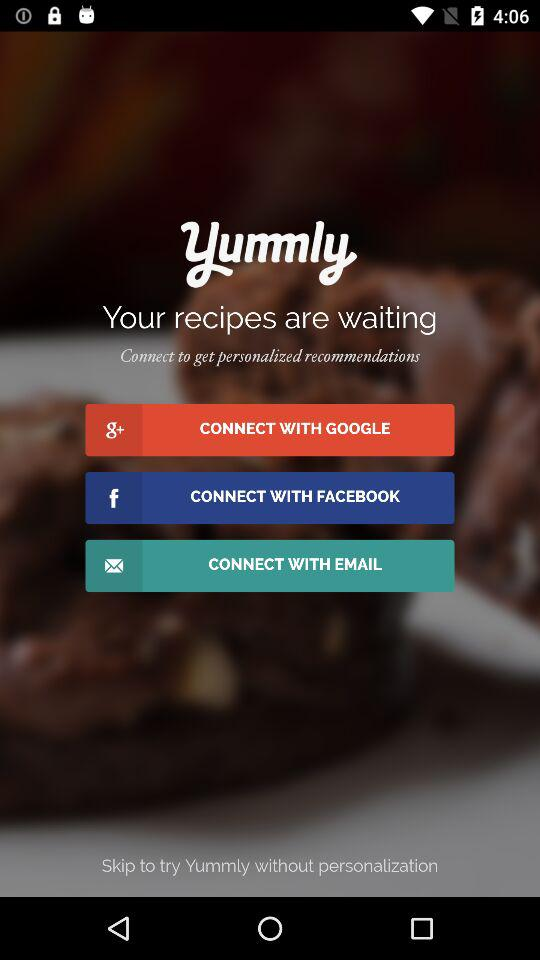What is the app name? The app name is "Yummly". 